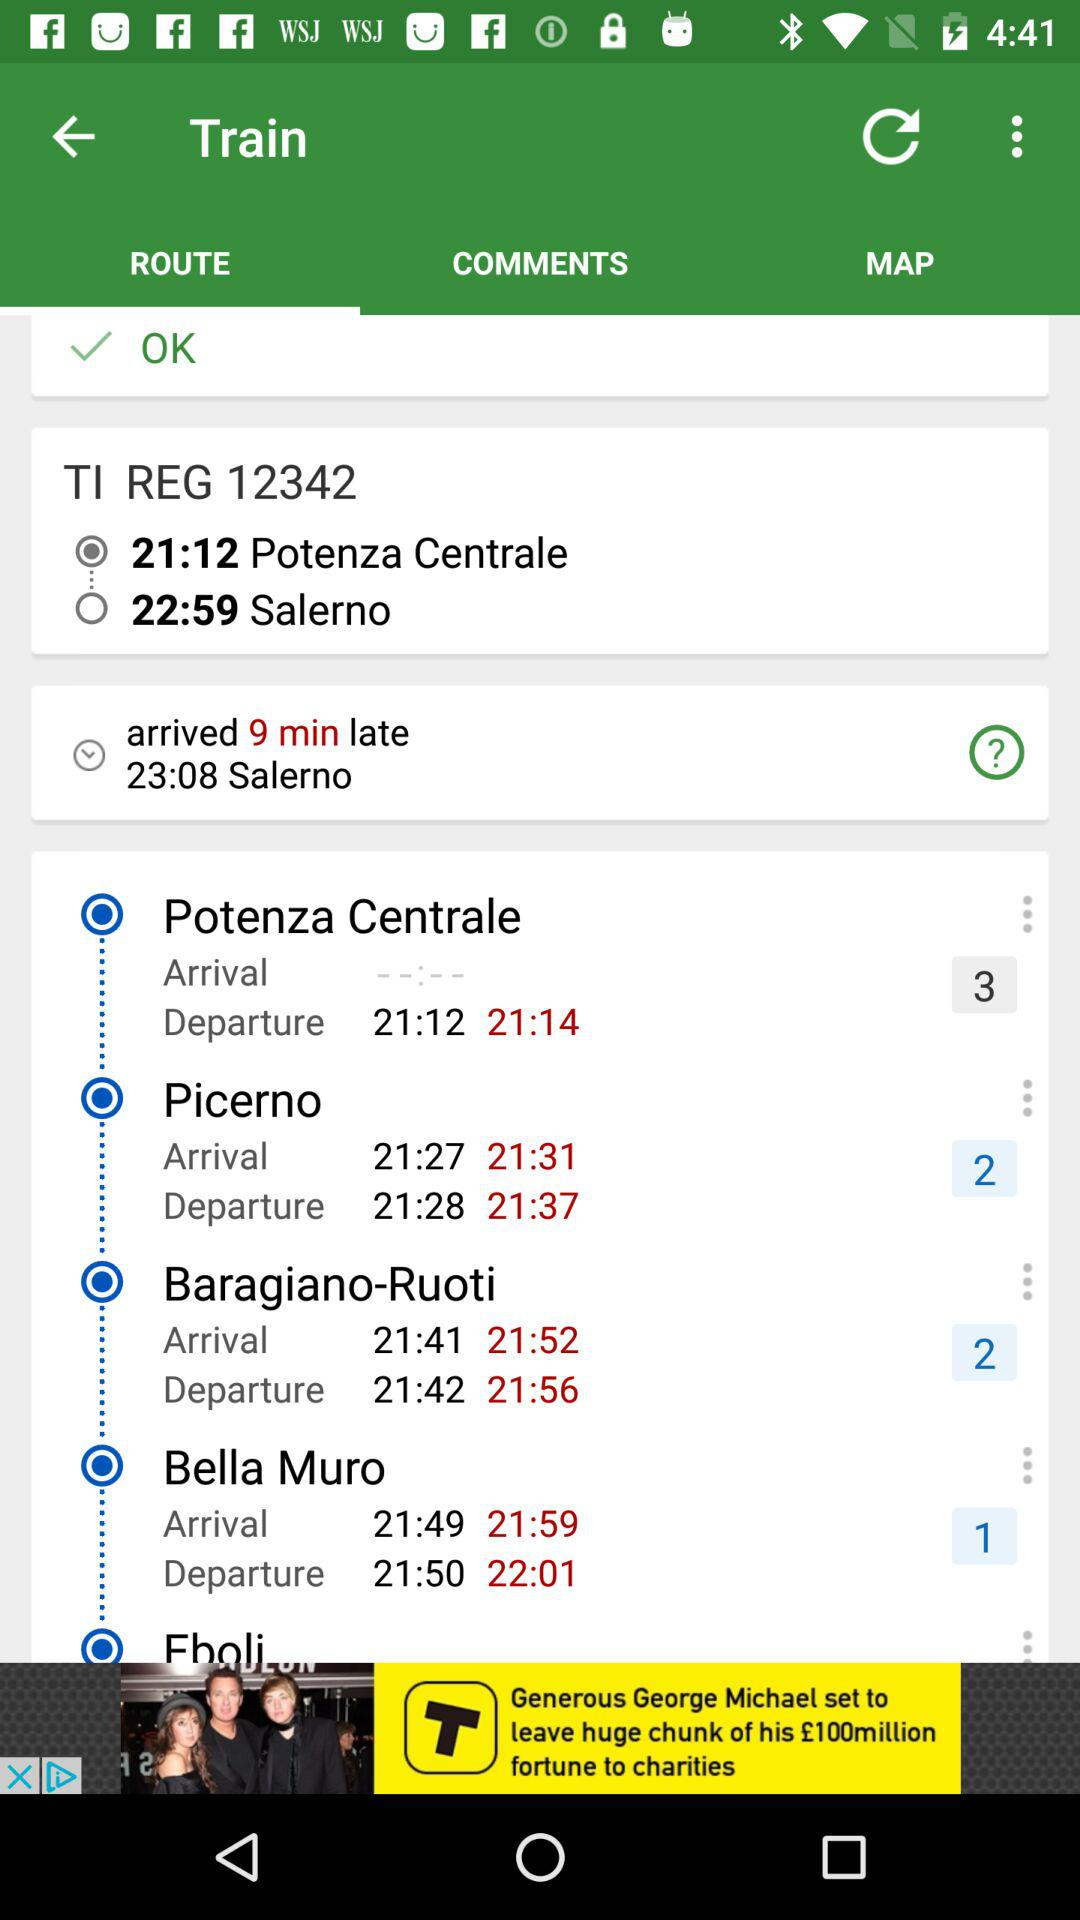At what time did the train arrive at "Salerno"? The train arrived at "Salerno" at 23:08. 